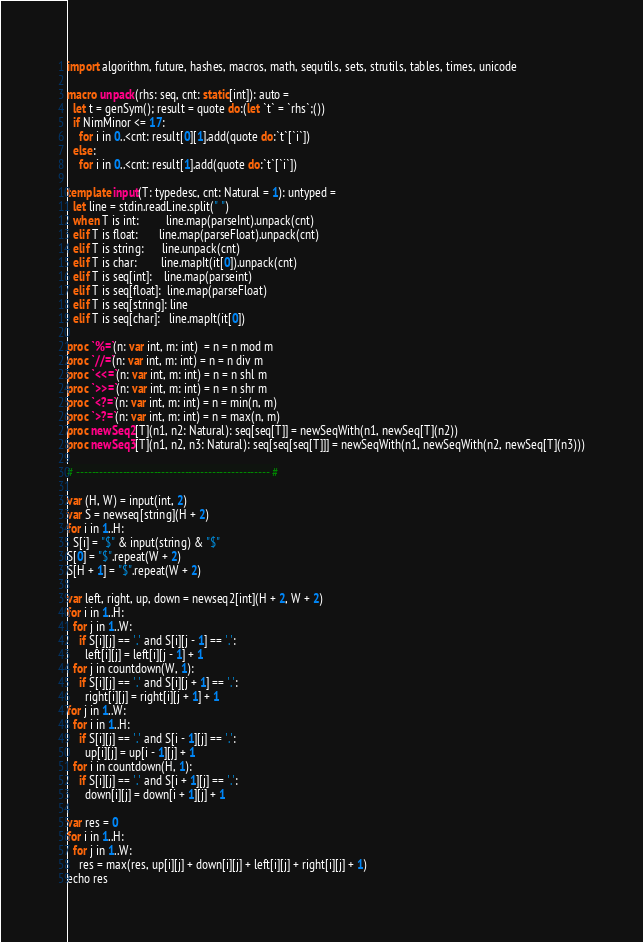<code> <loc_0><loc_0><loc_500><loc_500><_Nim_>import algorithm, future, hashes, macros, math, sequtils, sets, strutils, tables, times, unicode

macro unpack(rhs: seq, cnt: static[int]): auto =
  let t = genSym(); result = quote do:(let `t` = `rhs`;())
  if NimMinor <= 17:
    for i in 0..<cnt: result[0][1].add(quote do:`t`[`i`])
  else:
    for i in 0..<cnt: result[1].add(quote do:`t`[`i`])

template input(T: typedesc, cnt: Natural = 1): untyped =
  let line = stdin.readLine.split(" ")
  when T is int:         line.map(parseInt).unpack(cnt)
  elif T is float:       line.map(parseFloat).unpack(cnt)
  elif T is string:      line.unpack(cnt)
  elif T is char:        line.mapIt(it[0]).unpack(cnt)
  elif T is seq[int]:    line.map(parseint)
  elif T is seq[float]:  line.map(parseFloat)
  elif T is seq[string]: line
  elif T is seq[char]:   line.mapIt(it[0])

proc `%=`(n: var int, m: int)  = n = n mod m
proc `//=`(n: var int, m: int) = n = n div m
proc `<<=`(n: var int, m: int) = n = n shl m
proc `>>=`(n: var int, m: int) = n = n shr m
proc `<?=`(n: var int, m: int) = n = min(n, m)
proc `>?=`(n: var int, m: int) = n = max(n, m)
proc newSeq2[T](n1, n2: Natural): seq[seq[T]] = newSeqWith(n1, newSeq[T](n2))
proc newSeq3[T](n1, n2, n3: Natural): seq[seq[seq[T]]] = newSeqWith(n1, newSeqWith(n2, newSeq[T](n3)))

# -------------------------------------------------- #

var (H, W) = input(int, 2)
var S = newseq[string](H + 2)
for i in 1..H:
  S[i] = "$" & input(string) & "$"
S[0] = "$".repeat(W + 2)
S[H + 1] = "$".repeat(W + 2)

var left, right, up, down = newseq2[int](H + 2, W + 2)
for i in 1..H:
  for j in 1..W:
    if S[i][j] == '.' and S[i][j - 1] == '.':
      left[i][j] = left[i][j - 1] + 1
  for j in countdown(W, 1):
    if S[i][j] == '.' and S[i][j + 1] == '.':
      right[i][j] = right[i][j + 1] + 1
for j in 1..W:
  for i in 1..H:
    if S[i][j] == '.' and S[i - 1][j] == '.':
      up[i][j] = up[i - 1][j] + 1
  for i in countdown(H, 1):
    if S[i][j] == '.' and S[i + 1][j] == '.':
      down[i][j] = down[i + 1][j] + 1

var res = 0
for i in 1..H:
  for j in 1..W:
    res = max(res, up[i][j] + down[i][j] + left[i][j] + right[i][j] + 1)
echo res</code> 